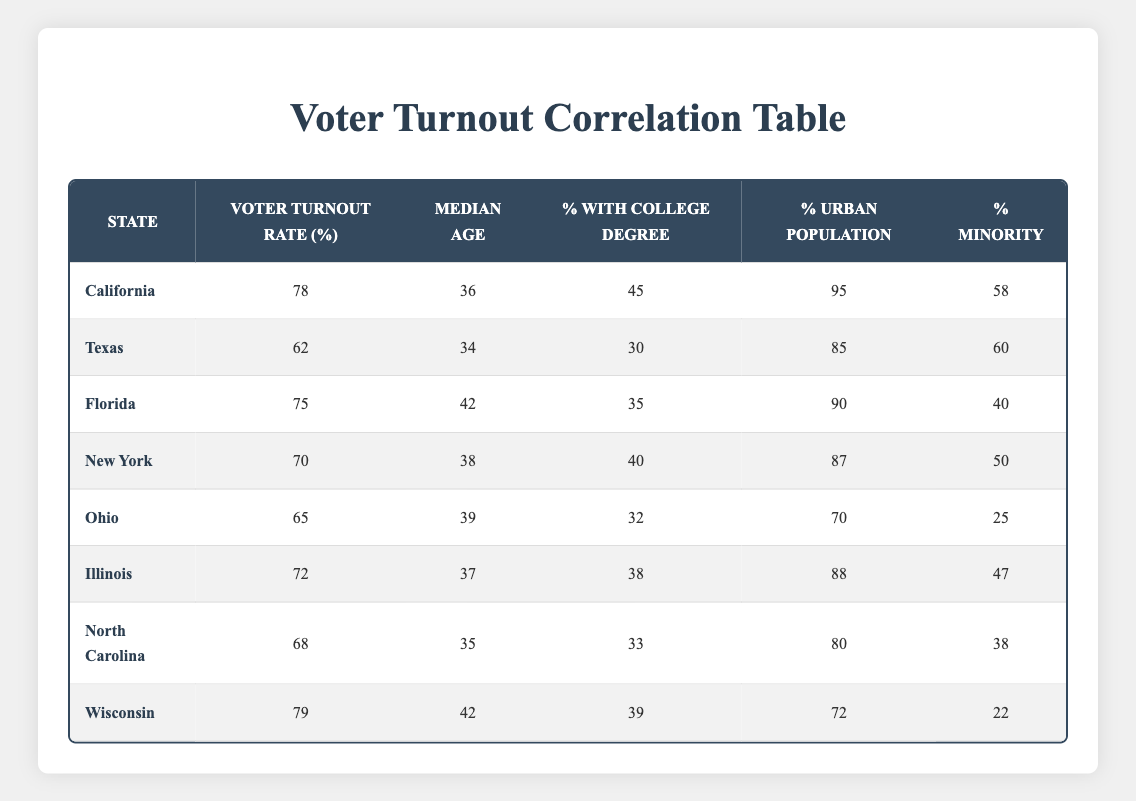What is the voter turnout rate in Texas? According to the table, the voter turnout rate for Texas is listed directly in the second column. It shows Texas has a voter turnout rate of 62%.
Answer: 62 Which state has the highest percentage of urban population? By examining the table, we can see that California has the highest percentage of urban population at 95%. This is the highest value in the fourth column, showing it directly.
Answer: 95 What is the average median age of states listed in the table? To find the average, add up all the median ages: 36 + 34 + 42 + 38 + 39 + 37 + 35 + 42 =  323. There are 8 states, so the average median age is 323 / 8 = 40.375.
Answer: 40.38 Is the voter turnout rate in Florida greater than the average voter turnout rate across all states? First, calculate the average voter turnout: (78 + 62 + 75 + 70 + 65 + 72 + 68 + 79) / 8 = 72.25. Florida has a voter turnout rate of 75, which is greater than 72.25.
Answer: Yes What is the difference in voter turnout rates between California and Ohio? The voter turnout rate for California is 78%, and for Ohio, it is 65%. Subtracting these gives 78 - 65 = 13. Thus, California has a higher voter turnout rate by 13%.
Answer: 13 